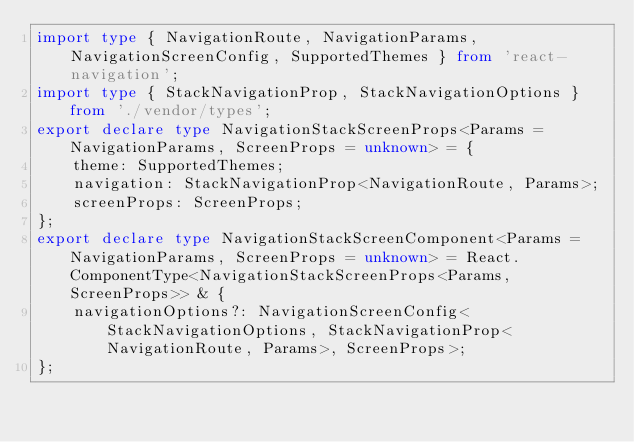<code> <loc_0><loc_0><loc_500><loc_500><_TypeScript_>import type { NavigationRoute, NavigationParams, NavigationScreenConfig, SupportedThemes } from 'react-navigation';
import type { StackNavigationProp, StackNavigationOptions } from './vendor/types';
export declare type NavigationStackScreenProps<Params = NavigationParams, ScreenProps = unknown> = {
    theme: SupportedThemes;
    navigation: StackNavigationProp<NavigationRoute, Params>;
    screenProps: ScreenProps;
};
export declare type NavigationStackScreenComponent<Params = NavigationParams, ScreenProps = unknown> = React.ComponentType<NavigationStackScreenProps<Params, ScreenProps>> & {
    navigationOptions?: NavigationScreenConfig<StackNavigationOptions, StackNavigationProp<NavigationRoute, Params>, ScreenProps>;
};
</code> 